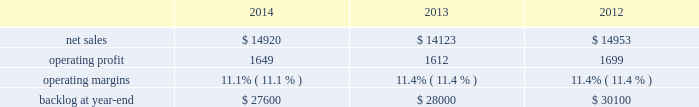2014 , 2013 and 2012 .
The decrease in our consolidated net adjustments for 2014 compared to 2013 was primarily due to a decrease in profit booking rate adjustments at our aeronautics , mfc and mst business segments .
The increase in our consolidated net adjustments for 2013 as compared to 2012 was primarily due to an increase in profit booking rate adjustments at our mst and mfc business segments and , to a lesser extent , the increase in the favorable resolution of contractual matters for the corporation .
The consolidated net adjustments for 2014 are inclusive of approximately $ 650 million in unfavorable items , which include reserves recorded on certain training and logistics solutions programs at mst and net warranty reserve adjustments for various programs ( including jassm and gmlrs ) at mfc as described in the respective business segment 2019s results of operations below .
The consolidated net adjustments for 2013 and 2012 are inclusive of approximately $ 600 million and $ 500 million in unfavorable items , which include a significant profit reduction on the f-35 development contract in both years , as well as a significant profit reduction on the c-5 program in 2013 , each as described in our aeronautics business segment 2019s results of operations discussion below .
Aeronautics our aeronautics business segment is engaged in the research , design , development , manufacture , integration , sustainment , support and upgrade of advanced military aircraft , including combat and air mobility aircraft , unmanned air vehicles and related technologies .
Aeronautics 2019 major programs include the f-35 lightning ii joint strike fighter , c-130 hercules , f-16 fighting falcon , f-22 raptor and the c-5m super galaxy .
Aeronautics 2019 operating results included the following ( in millions ) : .
2014 compared to 2013 aeronautics 2019 net sales for 2014 increased $ 797 million , or 6% ( 6 % ) , compared to 2013 .
The increase was primarily attributable to higher net sales of approximately $ 790 million for f-35 production contracts due to increased volume and sustainment activities ; about $ 55 million for the f-16 program due to increased deliveries ( 17 aircraft delivered in 2014 compared to 13 delivered in 2013 ) partially offset by contract mix ; and approximately $ 45 million for the f-22 program due to increased risk retirements .
The increases were partially offset by lower net sales of approximately $ 55 million for the f-35 development contract due to decreased volume , partially offset by the absence in 2014 of the downward revision to the profit booking rate that occurred in 2013 ; and about $ 40 million for the c-130 program due to fewer deliveries ( 24 aircraft delivered in 2014 compared to 25 delivered in 2013 ) and decreased sustainment activities , partially offset by contract mix .
Aeronautics 2019 operating profit for 2014 increased $ 37 million , or 2% ( 2 % ) , compared to 2013 .
The increase was primarily attributable to higher operating profit of approximately $ 85 million for the f-35 development contract due to the absence in 2014 of the downward revision to the profit booking rate that occurred in 2013 ; about $ 75 million for the f-22 program due to increased risk retirements ; approximately $ 50 million for the c-130 program due to increased risk retirements and contract mix , partially offset by fewer deliveries ; and about $ 25 million for the c-5 program due to the absence in 2014 of the downward revisions to the profit booking rate that occurred in 2013 .
The increases were partially offset by lower operating profit of approximately $ 130 million for the f-16 program due to decreased risk retirements , partially offset by increased deliveries ; and about $ 70 million for sustainment activities due to decreased risk retirements and volume .
Operating profit was comparable for f-35 production contracts as higher volume was offset by lower risk retirements .
Adjustments not related to volume , including net profit booking rate adjustments and other matters , were approximately $ 105 million lower for 2014 compared to 2013 .
2013 compared to 2012 aeronautics 2019 net sales for 2013 decreased $ 830 million , or 6% ( 6 % ) , compared to 2012 .
The decrease was primarily attributable to lower net sales of approximately $ 530 million for the f-16 program due to fewer aircraft deliveries ( 13 aircraft delivered in 2013 compared to 37 delivered in 2012 ) partially offset by aircraft configuration mix ; about $ 385 million for the c-130 program due to fewer aircraft deliveries ( 25 aircraft delivered in 2013 compared to 34 in 2012 ) partially offset by increased sustainment activities ; approximately $ 255 million for the f-22 program , which includes about $ 205 million due to .
What is the growth rate in operating profit for aeronautics in 2013? 
Computations: ((1612 - 1699) / 1699)
Answer: -0.05121. 